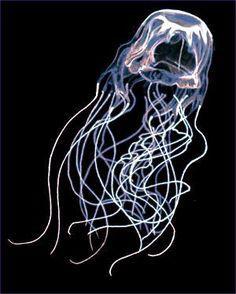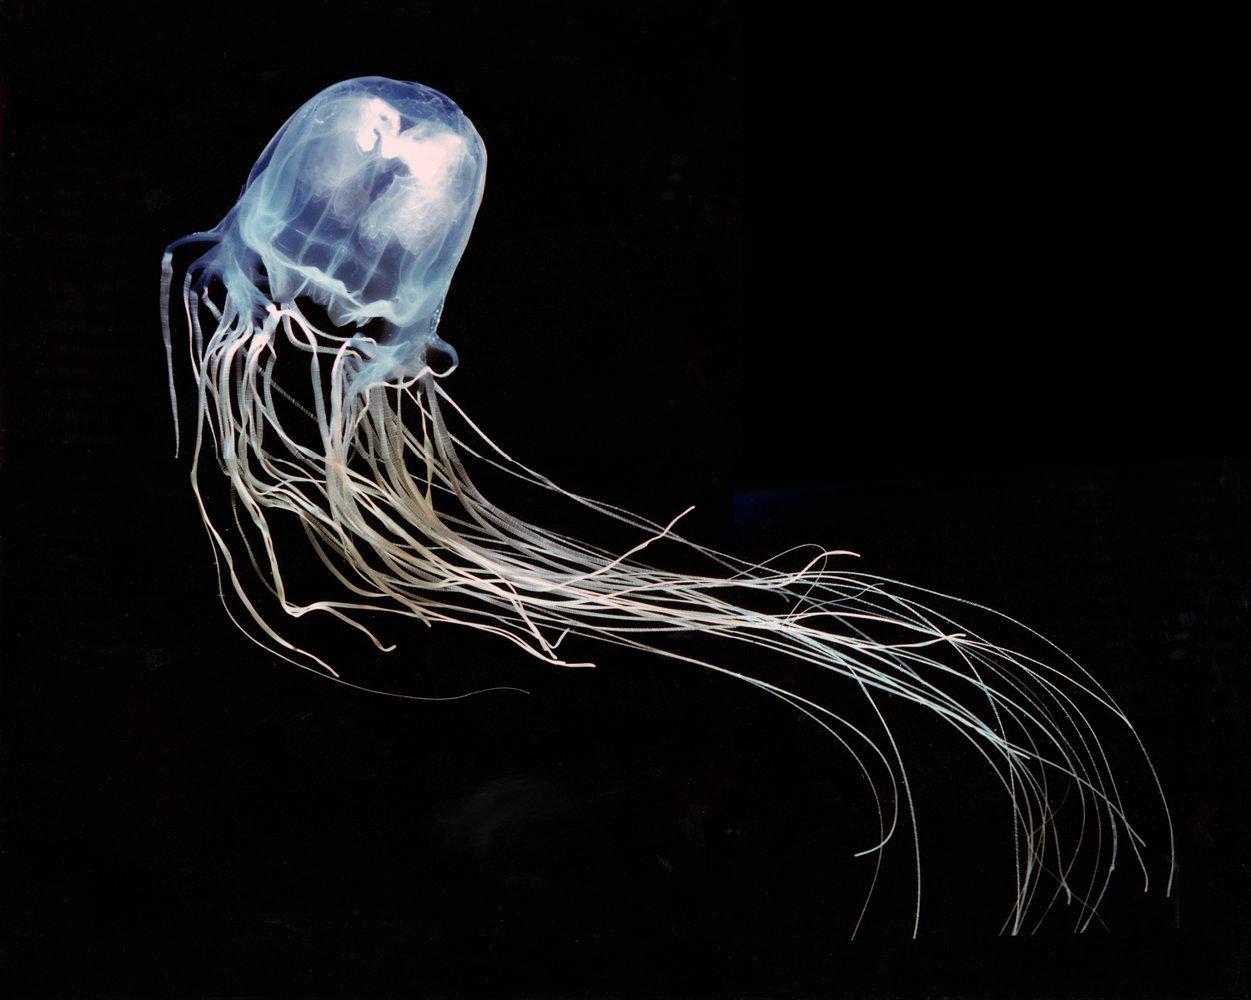The first image is the image on the left, the second image is the image on the right. Examine the images to the left and right. Is the description "Two jellyfish, one in each image, have similar body shape and color and long thread-like tendrills, but the tendrills are flowing back in differing directions." accurate? Answer yes or no. Yes. The first image is the image on the left, the second image is the image on the right. Assess this claim about the two images: "Each image shows a jellyfish with only long string-like tentacles trailing from a gumdrop-shaped body.". Correct or not? Answer yes or no. Yes. 